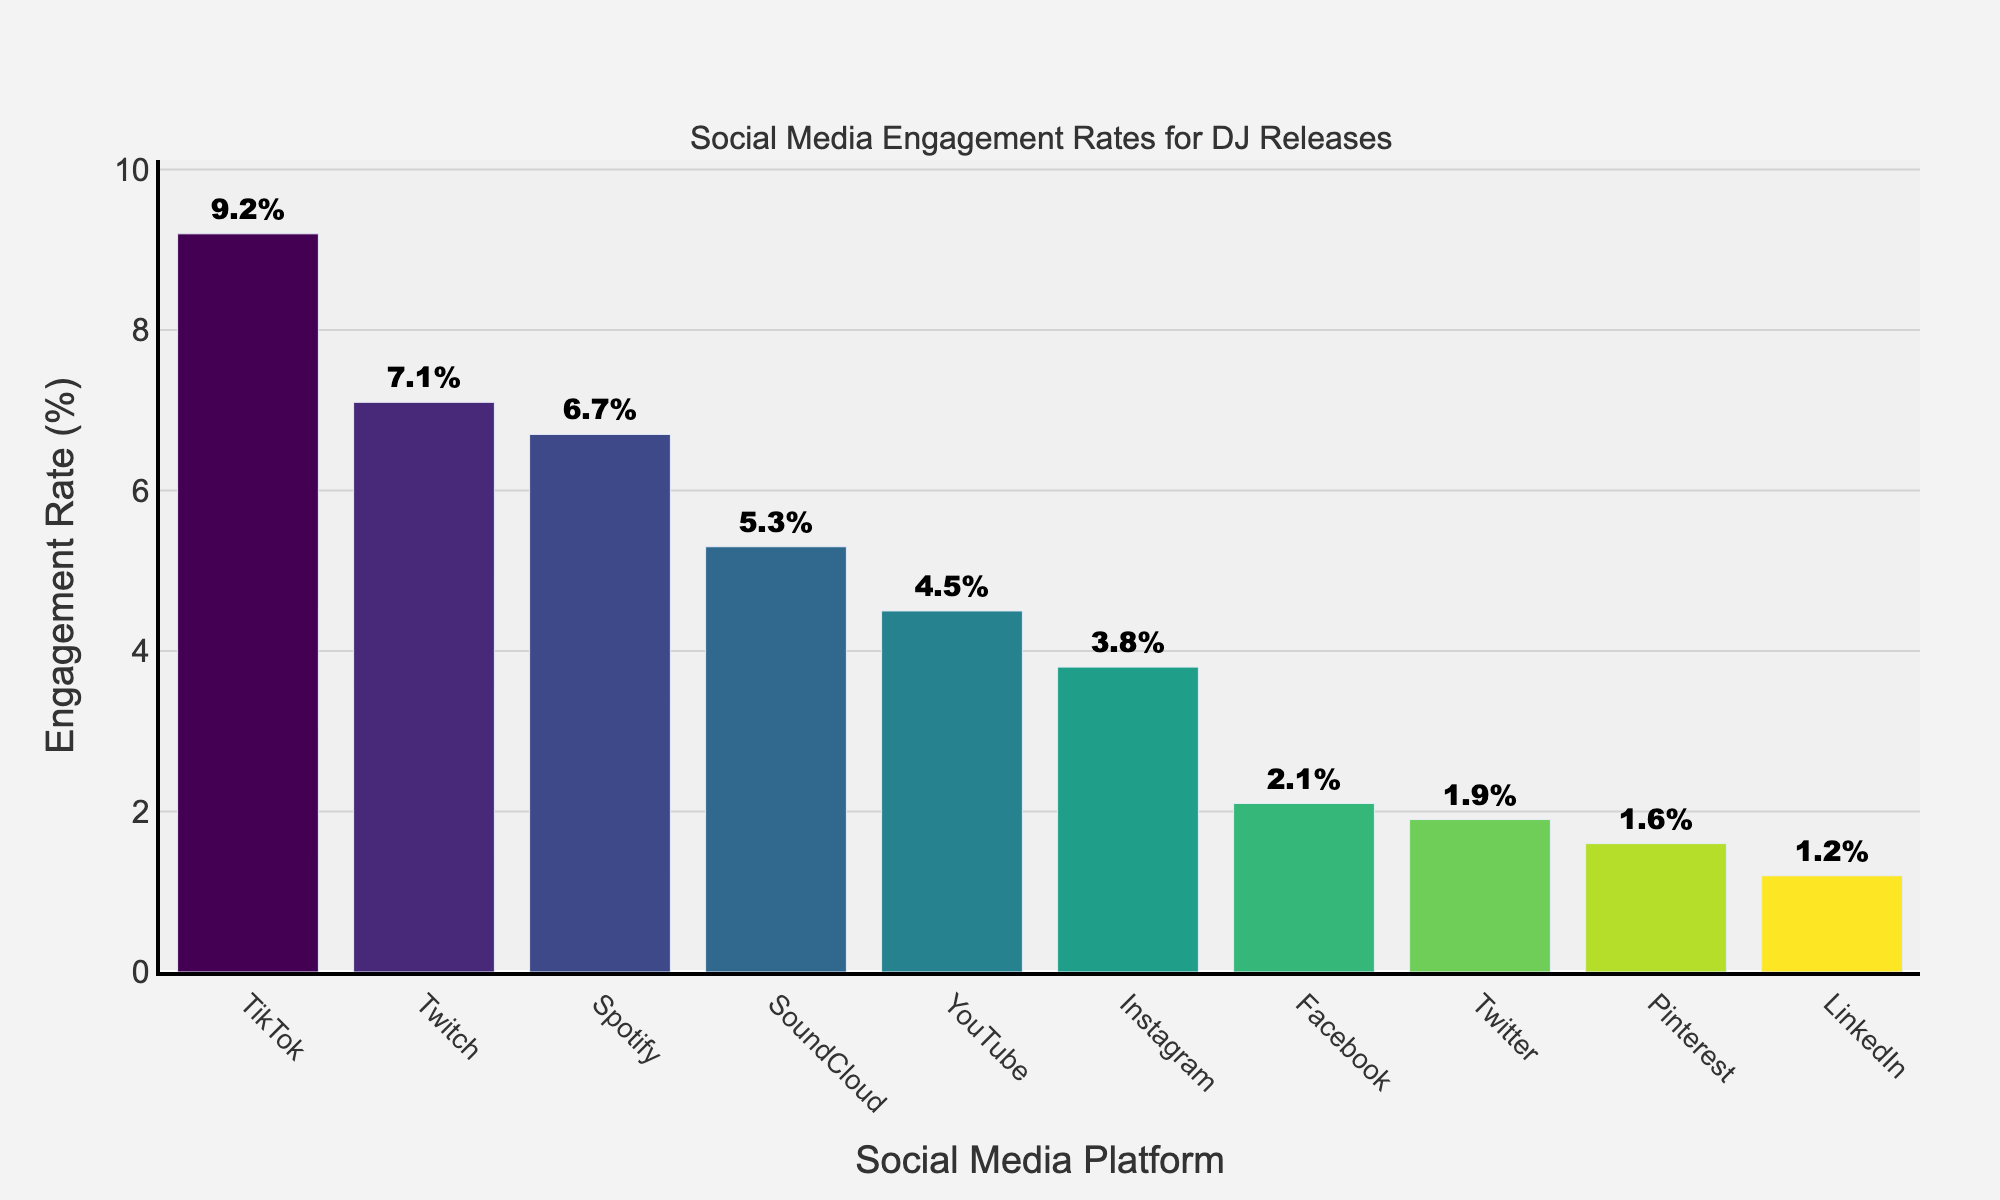Which platform has the highest engagement rate? The bar representing TikTok is the tallest, with an engagement rate of 9.2%.
Answer: TikTok Which platform has a higher engagement rate: YouTube or Spotify? The engagement rate for YouTube is 4.5%, while for Spotify it is 6.7%, so Spotify has a higher engagement rate.
Answer: Spotify What is the difference in engagement rates between Instagram and Facebook? Instagram has an engagement rate of 3.8%, and Facebook has 2.1%. The difference is 3.8% - 2.1% = 1.7%.
Answer: 1.7% Which platforms have engagement rates less than 2%? The platforms with engagement rates less than 2% are Twitter, LinkedIn, and Pinterest with rates of 1.9%, 1.2%, and 1.6% respectively.
Answer: Twitter, LinkedIn, Pinterest What is the average engagement rate of all the platforms? Sum all the engagement rates and divide by the number of platforms: (3.8 + 2.1 + 1.9 + 9.2 + 4.5 + 6.7 + 5.3 + 7.1 + 1.2 + 1.6) / 10 = 43.4 / 10 = 4.34%.
Answer: 4.34% Between SoundCloud and Twitch, which platform has a higher engagement rate and by how much? SoundCloud has an engagement rate of 5.3%, and Twitch has 7.1%. The difference is 7.1% - 5.3% = 1.8%.
Answer: Twitch by 1.8% How does the engagement rate of TikTok compare to LinkedIn? TikTok's engagement rate is 9.2%, whereas LinkedIn's is 1.2%. TikTok has a much higher rate by 9.2% - 1.2% = 8%.
Answer: TikTok is 8% higher Which platforms have an engagement rate of over 5%? The platforms with engagement rates over 5% are TikTok (9.2%), Spotify (6.7%), SoundCloud (5.3%), and Twitch (7.1%).
Answer: TikTok, Spotify, SoundCloud, Twitch Arrange the platforms in descending order of their engagement rates. Starting from the highest rate: TikTok (9.2%), Twitch (7.1%), Spotify (6.7%), SoundCloud (5.3%), YouTube (4.5%), Instagram (3.8%), Facebook (2.1%), Twitter (1.9%), Pinterest (1.6%), LinkedIn (1.2%).
Answer: TikTok, Twitch, Spotify, SoundCloud, YouTube, Instagram, Facebook, Twitter, Pinterest, LinkedIn What's the combined engagement rate of the top three platforms? The top three platforms are TikTok (9.2%), Twitch (7.1%), and Spotify (6.7%). The combined rate is 9.2% + 7.1% + 6.7% = 23%.
Answer: 23% 